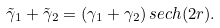Convert formula to latex. <formula><loc_0><loc_0><loc_500><loc_500>\tilde { \gamma } _ { 1 } + \tilde { \gamma } _ { 2 } = ( \gamma _ { 1 } + \gamma _ { 2 } ) \, s e c h ( 2 r ) .</formula> 